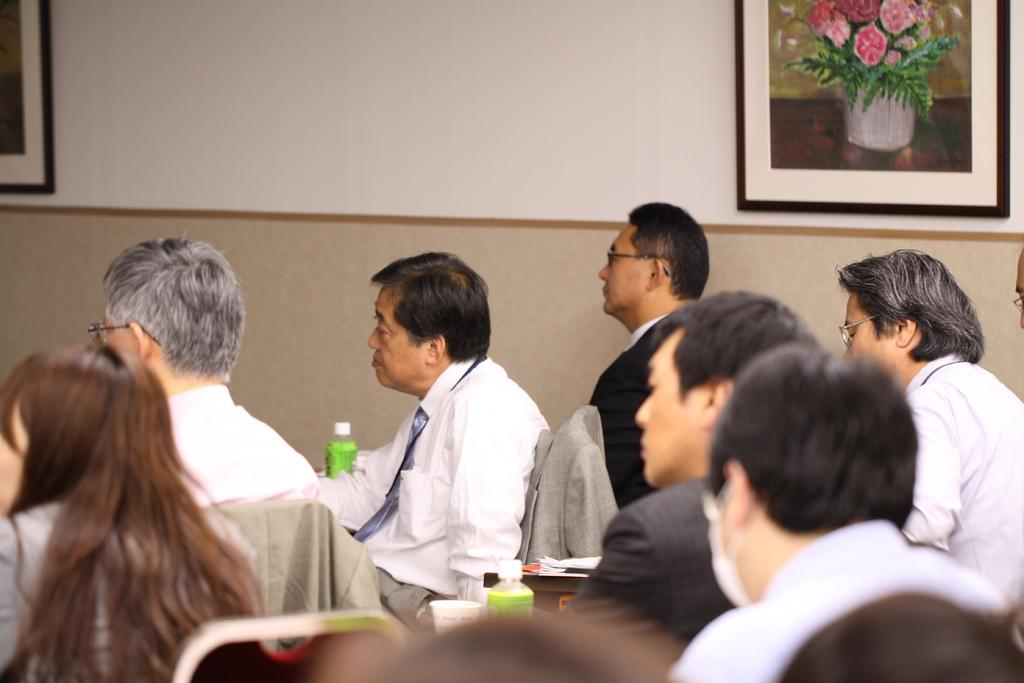How many people are in the image? There is a group of people in the image, but the exact number cannot be determined from the provided facts. What can be seen in the background of the image? There is a wall and photo frames in the background of the image. What time does the hour hand point to in the image? There is no clock or hour hand present in the image, so it is not possible to determine the time. 